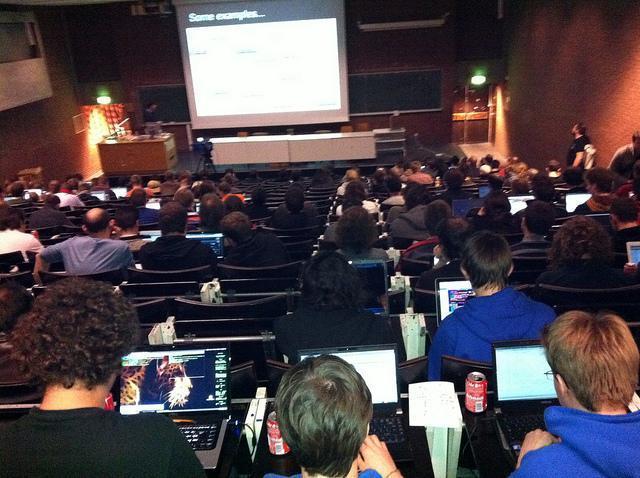How many laptops can be seen?
Give a very brief answer. 3. How many people are there?
Give a very brief answer. 10. How many chairs are in the photo?
Give a very brief answer. 3. How many bikes are there?
Give a very brief answer. 0. 